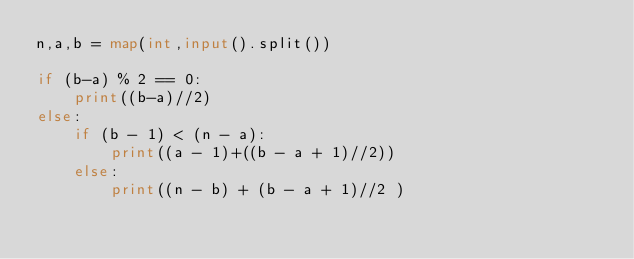<code> <loc_0><loc_0><loc_500><loc_500><_Python_>n,a,b = map(int,input().split())

if (b-a) % 2 == 0:
    print((b-a)//2)
else:
    if (b - 1) < (n - a):
        print((a - 1)+((b - a + 1)//2))
    else:
        print((n - b) + (b - a + 1)//2 )</code> 